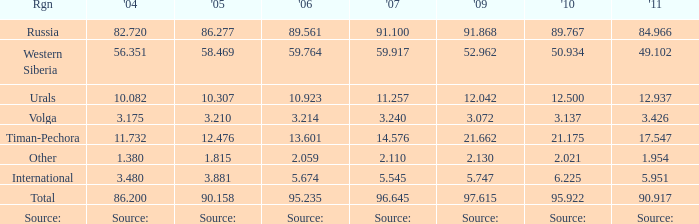What is the 2005 Lukoil oil prodroduction when in 2007 oil production 91.100 million tonnes? 86.277. 